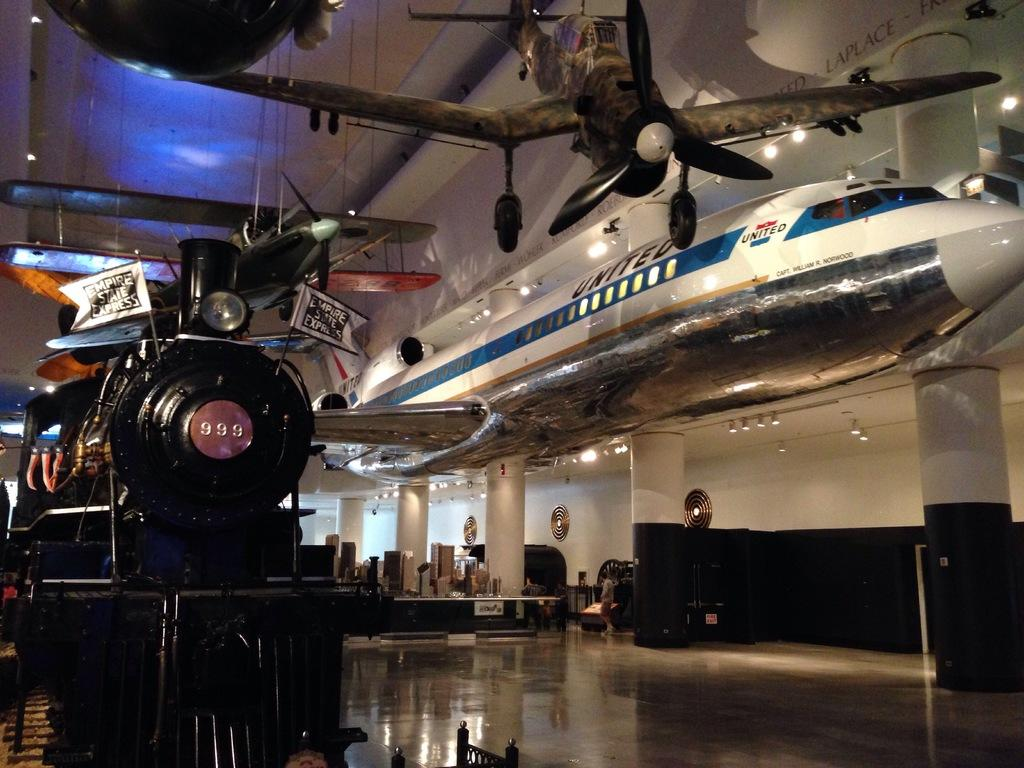<image>
Give a short and clear explanation of the subsequent image. A United airlines plane is suspended from the ceiling in a museum. 